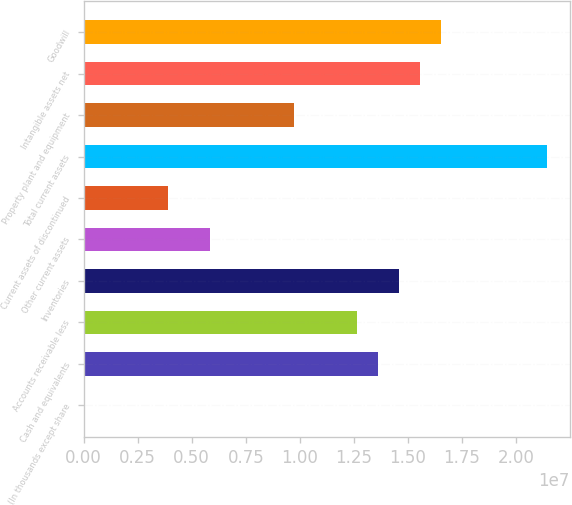<chart> <loc_0><loc_0><loc_500><loc_500><bar_chart><fcel>(In thousands except share<fcel>Cash and equivalents<fcel>Accounts receivable less<fcel>Inventories<fcel>Other current assets<fcel>Current assets of discontinued<fcel>Total current assets<fcel>Property plant and equipment<fcel>Intangible assets net<fcel>Goodwill<nl><fcel>2016<fcel>1.36342e+07<fcel>1.26605e+07<fcel>1.46079e+07<fcel>5.84438e+06<fcel>3.89692e+06<fcel>2.1424e+07<fcel>9.73929e+06<fcel>1.55816e+07<fcel>1.65554e+07<nl></chart> 